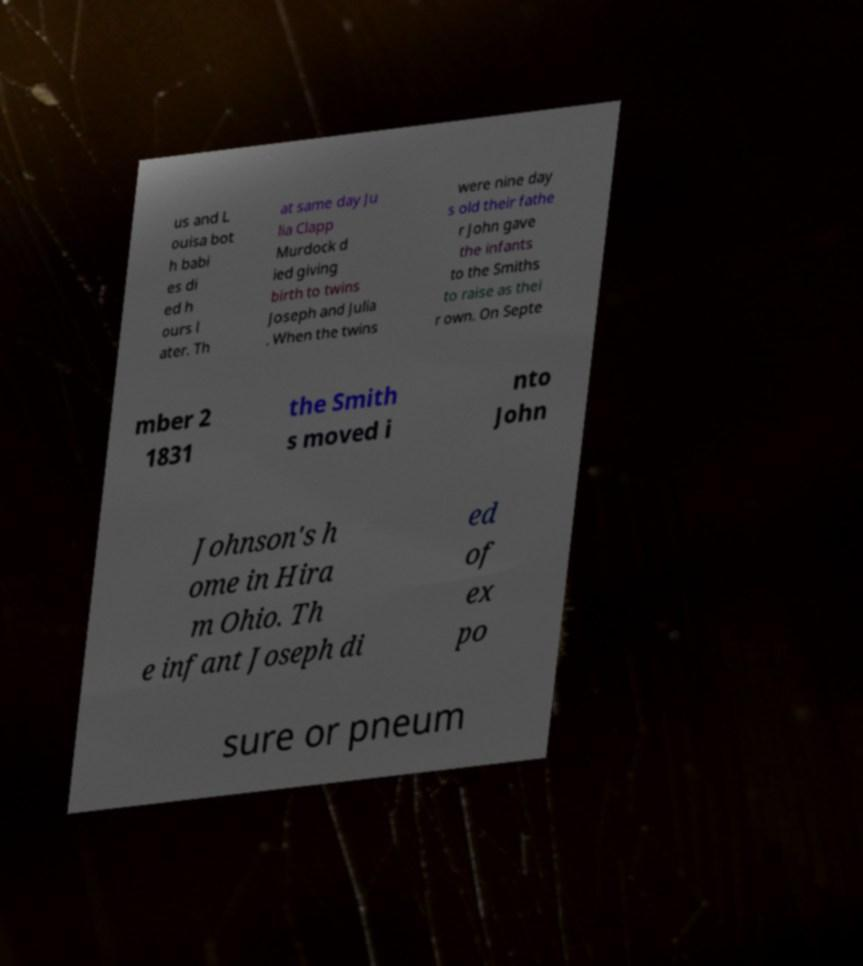For documentation purposes, I need the text within this image transcribed. Could you provide that? us and L ouisa bot h babi es di ed h ours l ater. Th at same day Ju lia Clapp Murdock d ied giving birth to twins Joseph and Julia . When the twins were nine day s old their fathe r John gave the infants to the Smiths to raise as thei r own. On Septe mber 2 1831 the Smith s moved i nto John Johnson's h ome in Hira m Ohio. Th e infant Joseph di ed of ex po sure or pneum 